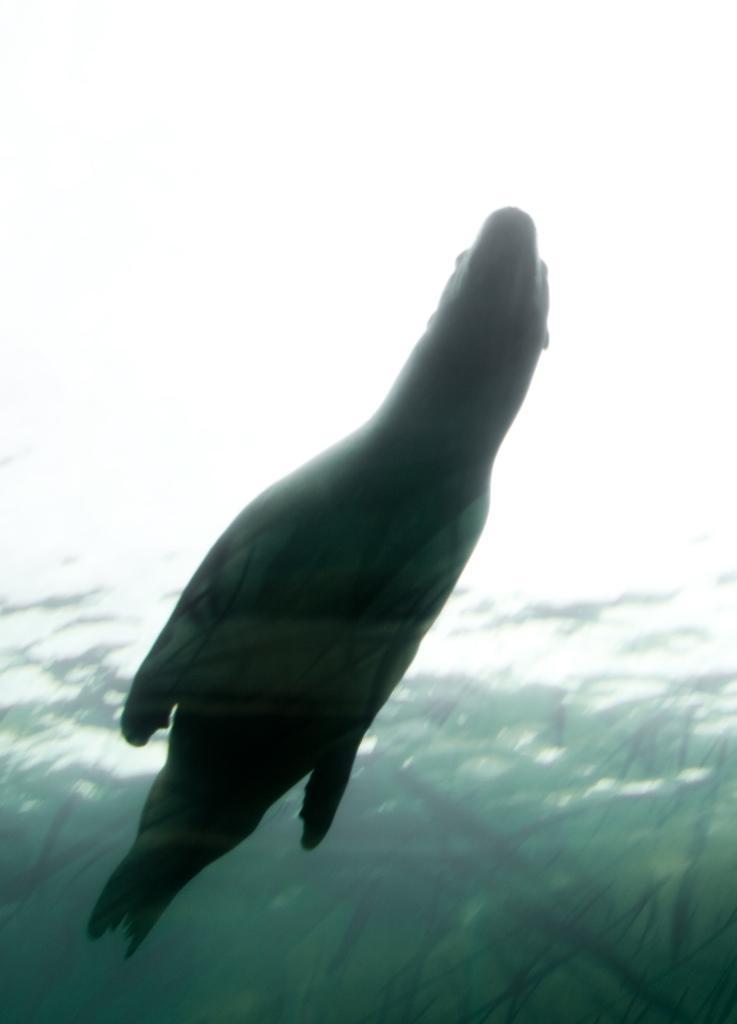Describe this image in one or two sentences. In this image we can see a dolphin swimming in the water. 